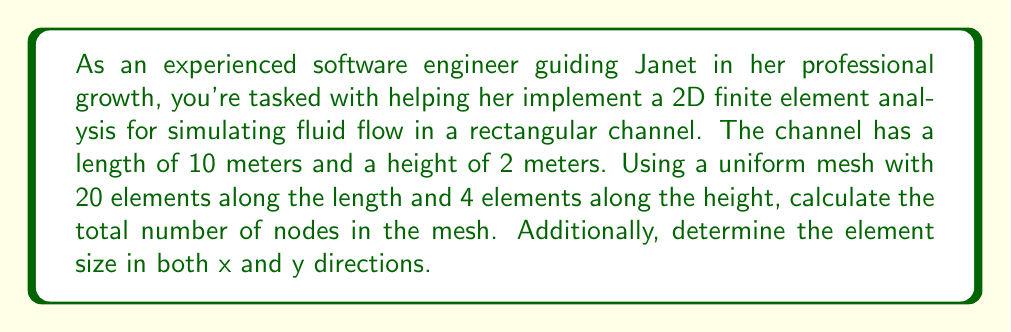Could you help me with this problem? To solve this problem, we need to follow these steps:

1. Understand the mesh structure:
   - The channel is discretized into rectangular elements.
   - We have 20 elements along the length (x-direction) and 4 elements along the height (y-direction).

2. Calculate the number of nodes:
   - In a rectangular mesh, the number of nodes in each direction is one more than the number of elements.
   - Number of nodes along length = 20 + 1 = 21
   - Number of nodes along height = 4 + 1 = 5
   - Total number of nodes = 21 × 5 = 105

3. Calculate the element size:
   - Element size in x-direction = Channel length / Number of elements along length
   - Element size in y-direction = Channel height / Number of elements along height

Let's perform the calculations:

Element size in x-direction:
$$ \Delta x = \frac{10 \text{ m}}{20} = 0.5 \text{ m} $$

Element size in y-direction:
$$ \Delta y = \frac{2 \text{ m}}{4} = 0.5 \text{ m} $$

The mesh structure can be visualized as follows:

[asy]
size(200,40);
for(int i=0; i<=20; ++i) {
  draw((i*0.5,0)--(i*0.5,2), gray);
}
for(int j=0; j<=4; ++j) {
  draw((0,j*0.5)--(10,j*0.5), gray);
}
draw((0,0)--(10,0)--(10,2)--(0,2)--cycle);
label("10 m", (5,-0.2));
label("2 m", (10.2,1), E);
[/asy]
Answer: Total number of nodes: 105
Element size in x-direction: $\Delta x = 0.5 \text{ m}$
Element size in y-direction: $\Delta y = 0.5 \text{ m}$ 